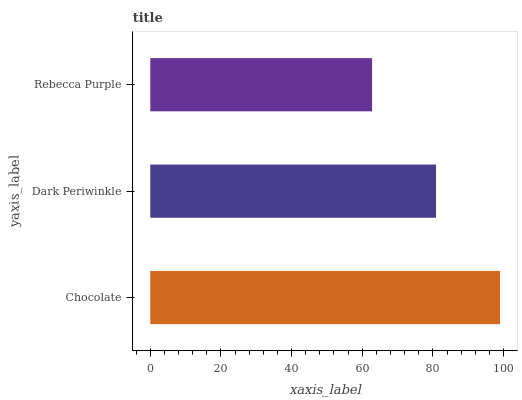Is Rebecca Purple the minimum?
Answer yes or no. Yes. Is Chocolate the maximum?
Answer yes or no. Yes. Is Dark Periwinkle the minimum?
Answer yes or no. No. Is Dark Periwinkle the maximum?
Answer yes or no. No. Is Chocolate greater than Dark Periwinkle?
Answer yes or no. Yes. Is Dark Periwinkle less than Chocolate?
Answer yes or no. Yes. Is Dark Periwinkle greater than Chocolate?
Answer yes or no. No. Is Chocolate less than Dark Periwinkle?
Answer yes or no. No. Is Dark Periwinkle the high median?
Answer yes or no. Yes. Is Dark Periwinkle the low median?
Answer yes or no. Yes. Is Rebecca Purple the high median?
Answer yes or no. No. Is Rebecca Purple the low median?
Answer yes or no. No. 